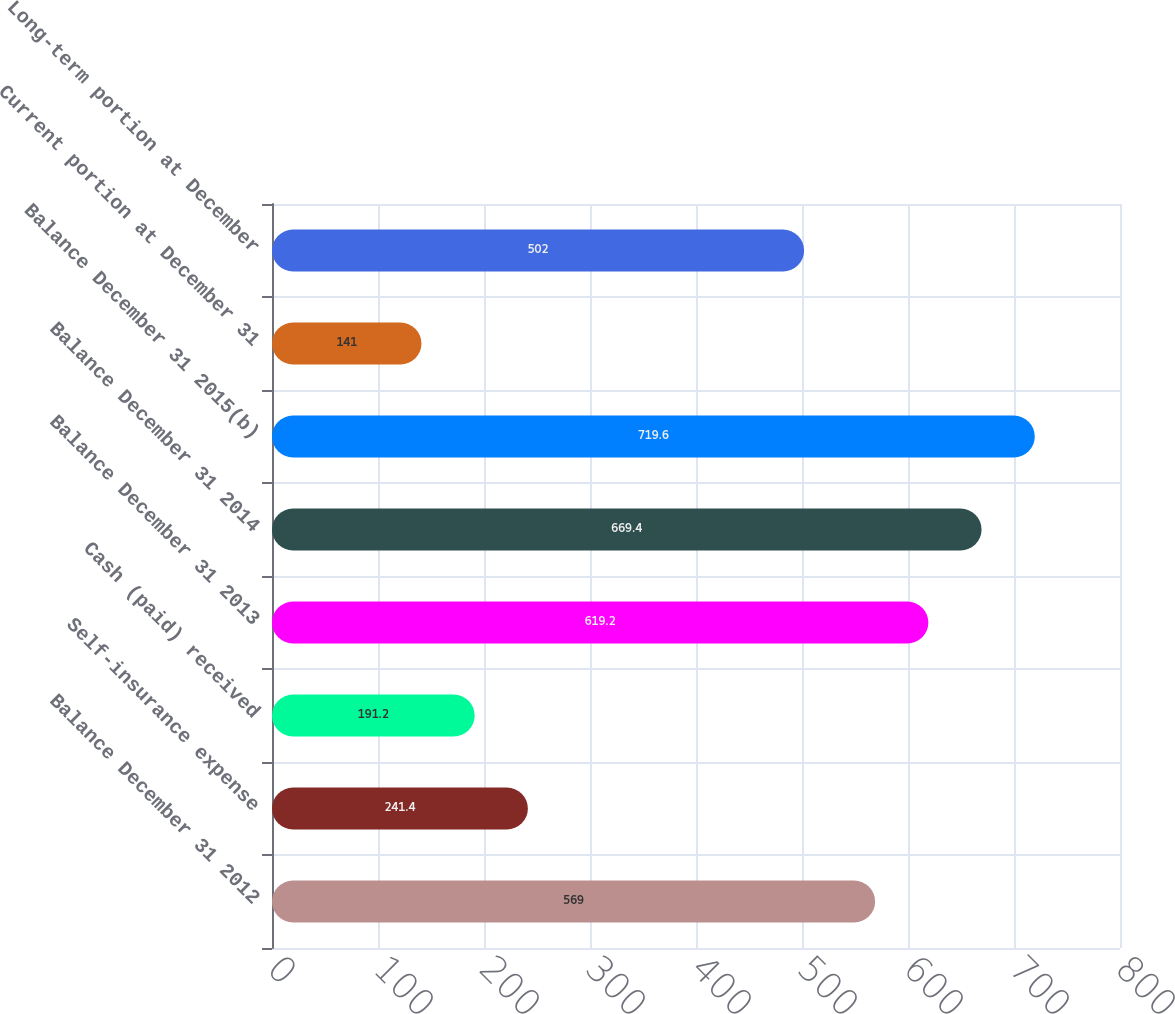Convert chart. <chart><loc_0><loc_0><loc_500><loc_500><bar_chart><fcel>Balance December 31 2012<fcel>Self-insurance expense<fcel>Cash (paid) received<fcel>Balance December 31 2013<fcel>Balance December 31 2014<fcel>Balance December 31 2015(b)<fcel>Current portion at December 31<fcel>Long-term portion at December<nl><fcel>569<fcel>241.4<fcel>191.2<fcel>619.2<fcel>669.4<fcel>719.6<fcel>141<fcel>502<nl></chart> 